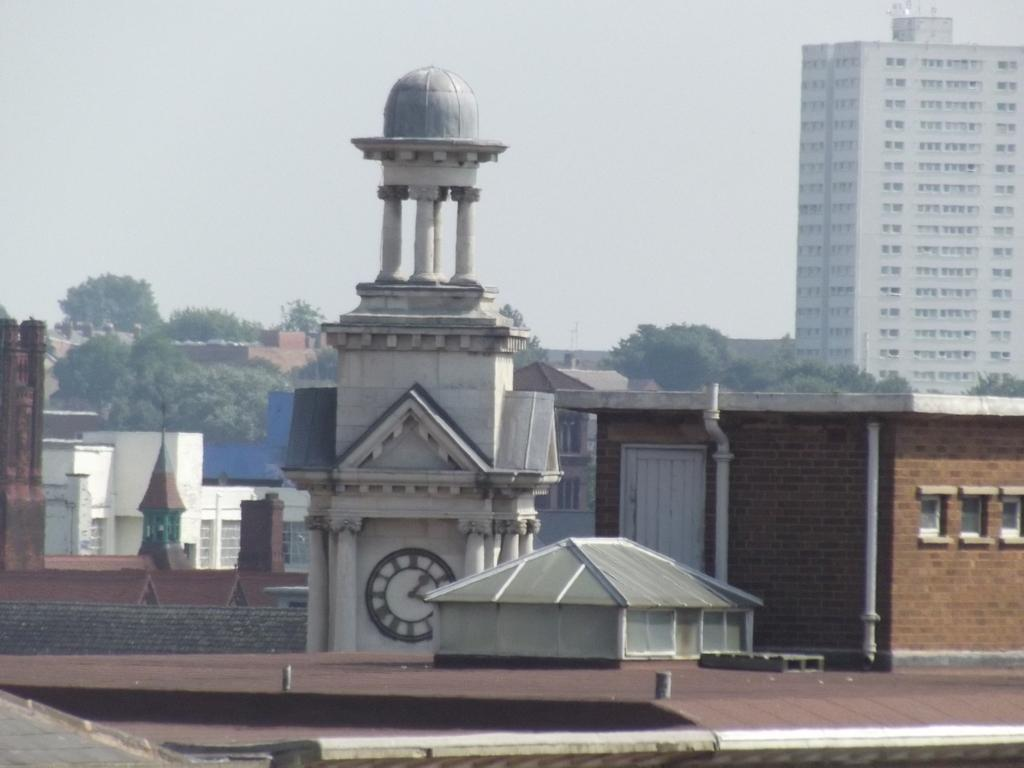What type of structures can be seen in the image? There are buildings in the image. What type of vegetation is present in the image? There are trees in the image. What type of tin can be seen in the image? There is no tin present in the image. What type of society is depicted in the image? The image does not depict a society; it only shows buildings and trees. 